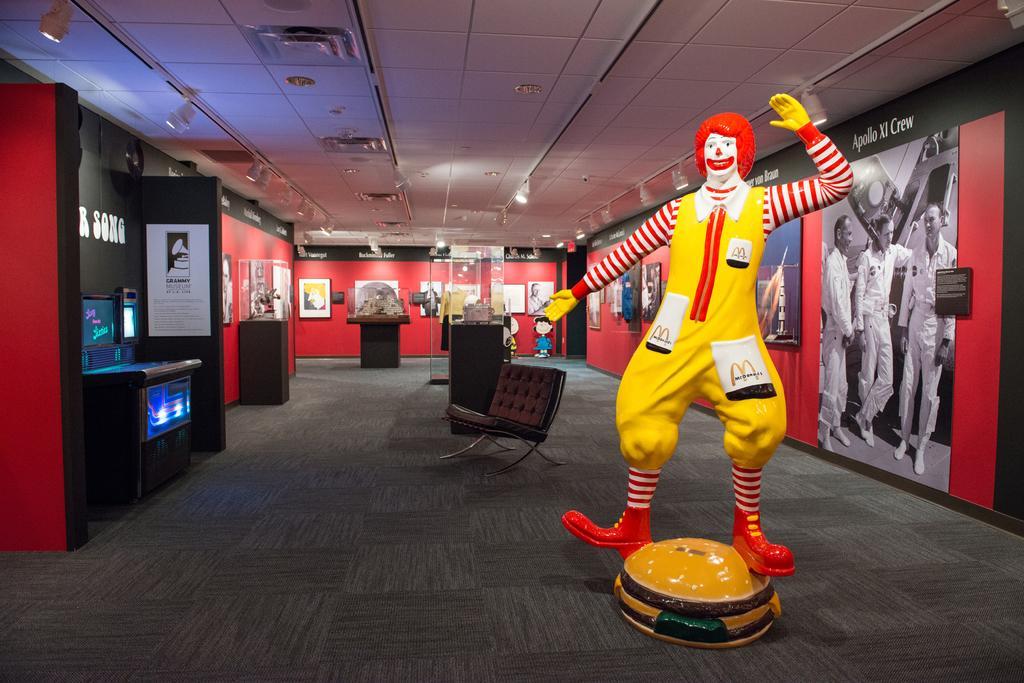How would you summarize this image in a sentence or two? This is an inside view of a room. On the right side there is a statue of a person. In the background there are many posters and frames are attached the walls. There are many tables and a chair on the floor. On the left side there is a machine tool. At the top of the image there are few lights to the roof. 